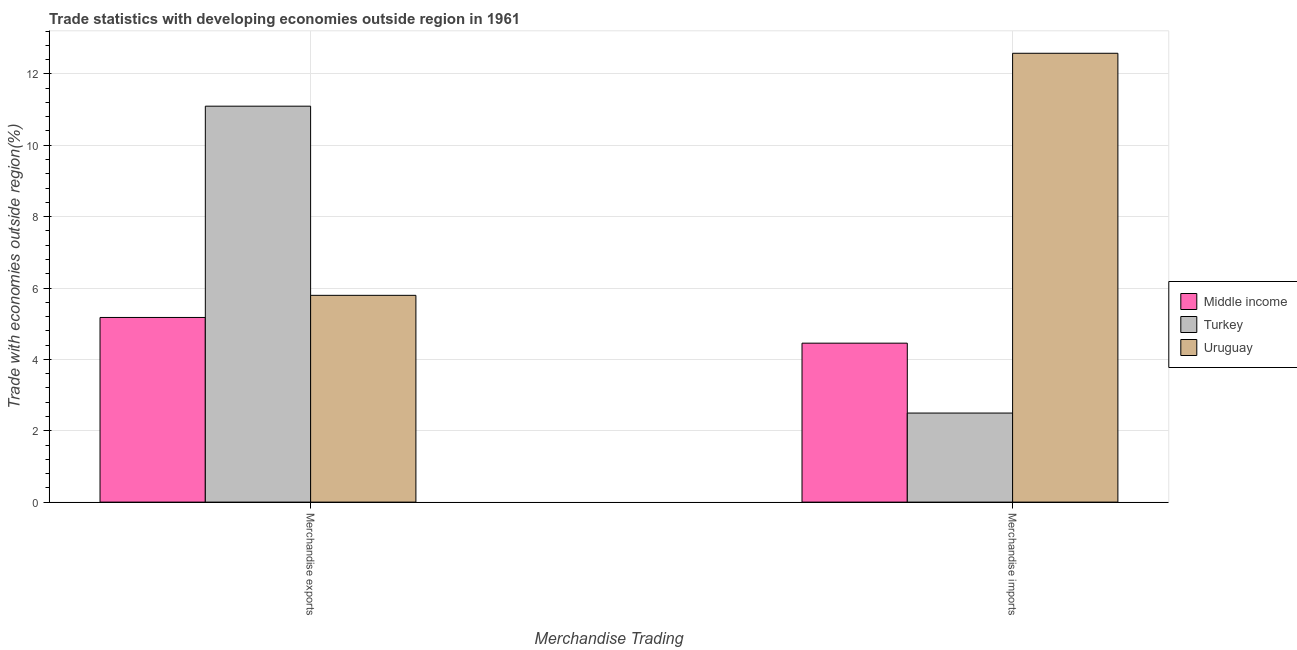Are the number of bars per tick equal to the number of legend labels?
Offer a terse response. Yes. Are the number of bars on each tick of the X-axis equal?
Your answer should be compact. Yes. How many bars are there on the 1st tick from the right?
Ensure brevity in your answer.  3. What is the merchandise imports in Uruguay?
Give a very brief answer. 12.58. Across all countries, what is the maximum merchandise imports?
Make the answer very short. 12.58. Across all countries, what is the minimum merchandise exports?
Your answer should be compact. 5.17. In which country was the merchandise imports maximum?
Make the answer very short. Uruguay. What is the total merchandise exports in the graph?
Your answer should be very brief. 22.06. What is the difference between the merchandise exports in Uruguay and that in Middle income?
Keep it short and to the point. 0.62. What is the difference between the merchandise imports in Uruguay and the merchandise exports in Turkey?
Make the answer very short. 1.48. What is the average merchandise exports per country?
Your answer should be very brief. 7.35. What is the difference between the merchandise exports and merchandise imports in Middle income?
Provide a succinct answer. 0.72. In how many countries, is the merchandise imports greater than 5.6 %?
Provide a short and direct response. 1. What is the ratio of the merchandise imports in Turkey to that in Uruguay?
Give a very brief answer. 0.2. Is the merchandise imports in Middle income less than that in Uruguay?
Provide a short and direct response. Yes. In how many countries, is the merchandise imports greater than the average merchandise imports taken over all countries?
Your answer should be very brief. 1. What does the 3rd bar from the left in Merchandise exports represents?
Ensure brevity in your answer.  Uruguay. What does the 1st bar from the right in Merchandise exports represents?
Your answer should be very brief. Uruguay. Does the graph contain any zero values?
Provide a short and direct response. No. Where does the legend appear in the graph?
Give a very brief answer. Center right. How many legend labels are there?
Your answer should be very brief. 3. What is the title of the graph?
Your response must be concise. Trade statistics with developing economies outside region in 1961. What is the label or title of the X-axis?
Your response must be concise. Merchandise Trading. What is the label or title of the Y-axis?
Your answer should be very brief. Trade with economies outside region(%). What is the Trade with economies outside region(%) of Middle income in Merchandise exports?
Keep it short and to the point. 5.17. What is the Trade with economies outside region(%) in Turkey in Merchandise exports?
Offer a terse response. 11.1. What is the Trade with economies outside region(%) of Uruguay in Merchandise exports?
Your response must be concise. 5.79. What is the Trade with economies outside region(%) in Middle income in Merchandise imports?
Your answer should be very brief. 4.45. What is the Trade with economies outside region(%) of Turkey in Merchandise imports?
Keep it short and to the point. 2.5. What is the Trade with economies outside region(%) of Uruguay in Merchandise imports?
Keep it short and to the point. 12.58. Across all Merchandise Trading, what is the maximum Trade with economies outside region(%) of Middle income?
Offer a terse response. 5.17. Across all Merchandise Trading, what is the maximum Trade with economies outside region(%) in Turkey?
Your response must be concise. 11.1. Across all Merchandise Trading, what is the maximum Trade with economies outside region(%) of Uruguay?
Offer a terse response. 12.58. Across all Merchandise Trading, what is the minimum Trade with economies outside region(%) in Middle income?
Provide a short and direct response. 4.45. Across all Merchandise Trading, what is the minimum Trade with economies outside region(%) of Turkey?
Ensure brevity in your answer.  2.5. Across all Merchandise Trading, what is the minimum Trade with economies outside region(%) in Uruguay?
Your response must be concise. 5.79. What is the total Trade with economies outside region(%) in Middle income in the graph?
Ensure brevity in your answer.  9.63. What is the total Trade with economies outside region(%) in Turkey in the graph?
Your response must be concise. 13.59. What is the total Trade with economies outside region(%) of Uruguay in the graph?
Provide a succinct answer. 18.37. What is the difference between the Trade with economies outside region(%) in Middle income in Merchandise exports and that in Merchandise imports?
Offer a terse response. 0.72. What is the difference between the Trade with economies outside region(%) in Turkey in Merchandise exports and that in Merchandise imports?
Give a very brief answer. 8.6. What is the difference between the Trade with economies outside region(%) in Uruguay in Merchandise exports and that in Merchandise imports?
Your answer should be very brief. -6.78. What is the difference between the Trade with economies outside region(%) of Middle income in Merchandise exports and the Trade with economies outside region(%) of Turkey in Merchandise imports?
Give a very brief answer. 2.68. What is the difference between the Trade with economies outside region(%) of Middle income in Merchandise exports and the Trade with economies outside region(%) of Uruguay in Merchandise imports?
Your answer should be very brief. -7.4. What is the difference between the Trade with economies outside region(%) of Turkey in Merchandise exports and the Trade with economies outside region(%) of Uruguay in Merchandise imports?
Your answer should be very brief. -1.48. What is the average Trade with economies outside region(%) in Middle income per Merchandise Trading?
Your response must be concise. 4.81. What is the average Trade with economies outside region(%) in Turkey per Merchandise Trading?
Keep it short and to the point. 6.8. What is the average Trade with economies outside region(%) in Uruguay per Merchandise Trading?
Your answer should be compact. 9.19. What is the difference between the Trade with economies outside region(%) in Middle income and Trade with economies outside region(%) in Turkey in Merchandise exports?
Provide a short and direct response. -5.92. What is the difference between the Trade with economies outside region(%) of Middle income and Trade with economies outside region(%) of Uruguay in Merchandise exports?
Your response must be concise. -0.62. What is the difference between the Trade with economies outside region(%) of Turkey and Trade with economies outside region(%) of Uruguay in Merchandise exports?
Offer a terse response. 5.3. What is the difference between the Trade with economies outside region(%) of Middle income and Trade with economies outside region(%) of Turkey in Merchandise imports?
Your answer should be very brief. 1.96. What is the difference between the Trade with economies outside region(%) of Middle income and Trade with economies outside region(%) of Uruguay in Merchandise imports?
Provide a succinct answer. -8.12. What is the difference between the Trade with economies outside region(%) in Turkey and Trade with economies outside region(%) in Uruguay in Merchandise imports?
Make the answer very short. -10.08. What is the ratio of the Trade with economies outside region(%) in Middle income in Merchandise exports to that in Merchandise imports?
Give a very brief answer. 1.16. What is the ratio of the Trade with economies outside region(%) of Turkey in Merchandise exports to that in Merchandise imports?
Keep it short and to the point. 4.45. What is the ratio of the Trade with economies outside region(%) of Uruguay in Merchandise exports to that in Merchandise imports?
Make the answer very short. 0.46. What is the difference between the highest and the second highest Trade with economies outside region(%) of Middle income?
Make the answer very short. 0.72. What is the difference between the highest and the second highest Trade with economies outside region(%) in Turkey?
Make the answer very short. 8.6. What is the difference between the highest and the second highest Trade with economies outside region(%) in Uruguay?
Give a very brief answer. 6.78. What is the difference between the highest and the lowest Trade with economies outside region(%) in Middle income?
Your answer should be compact. 0.72. What is the difference between the highest and the lowest Trade with economies outside region(%) of Turkey?
Your response must be concise. 8.6. What is the difference between the highest and the lowest Trade with economies outside region(%) of Uruguay?
Make the answer very short. 6.78. 